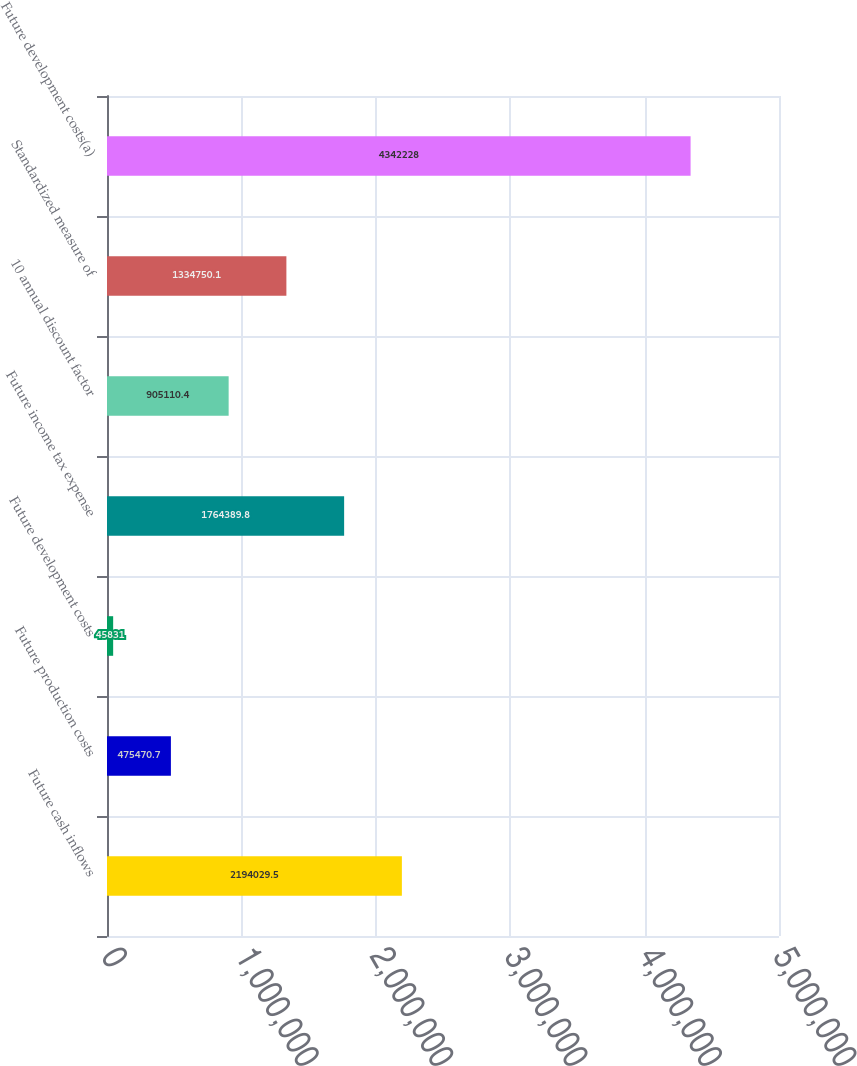Convert chart. <chart><loc_0><loc_0><loc_500><loc_500><bar_chart><fcel>Future cash inflows<fcel>Future production costs<fcel>Future development costs<fcel>Future income tax expense<fcel>10 annual discount factor<fcel>Standardized measure of<fcel>Future development costs(a)<nl><fcel>2.19403e+06<fcel>475471<fcel>45831<fcel>1.76439e+06<fcel>905110<fcel>1.33475e+06<fcel>4.34223e+06<nl></chart> 